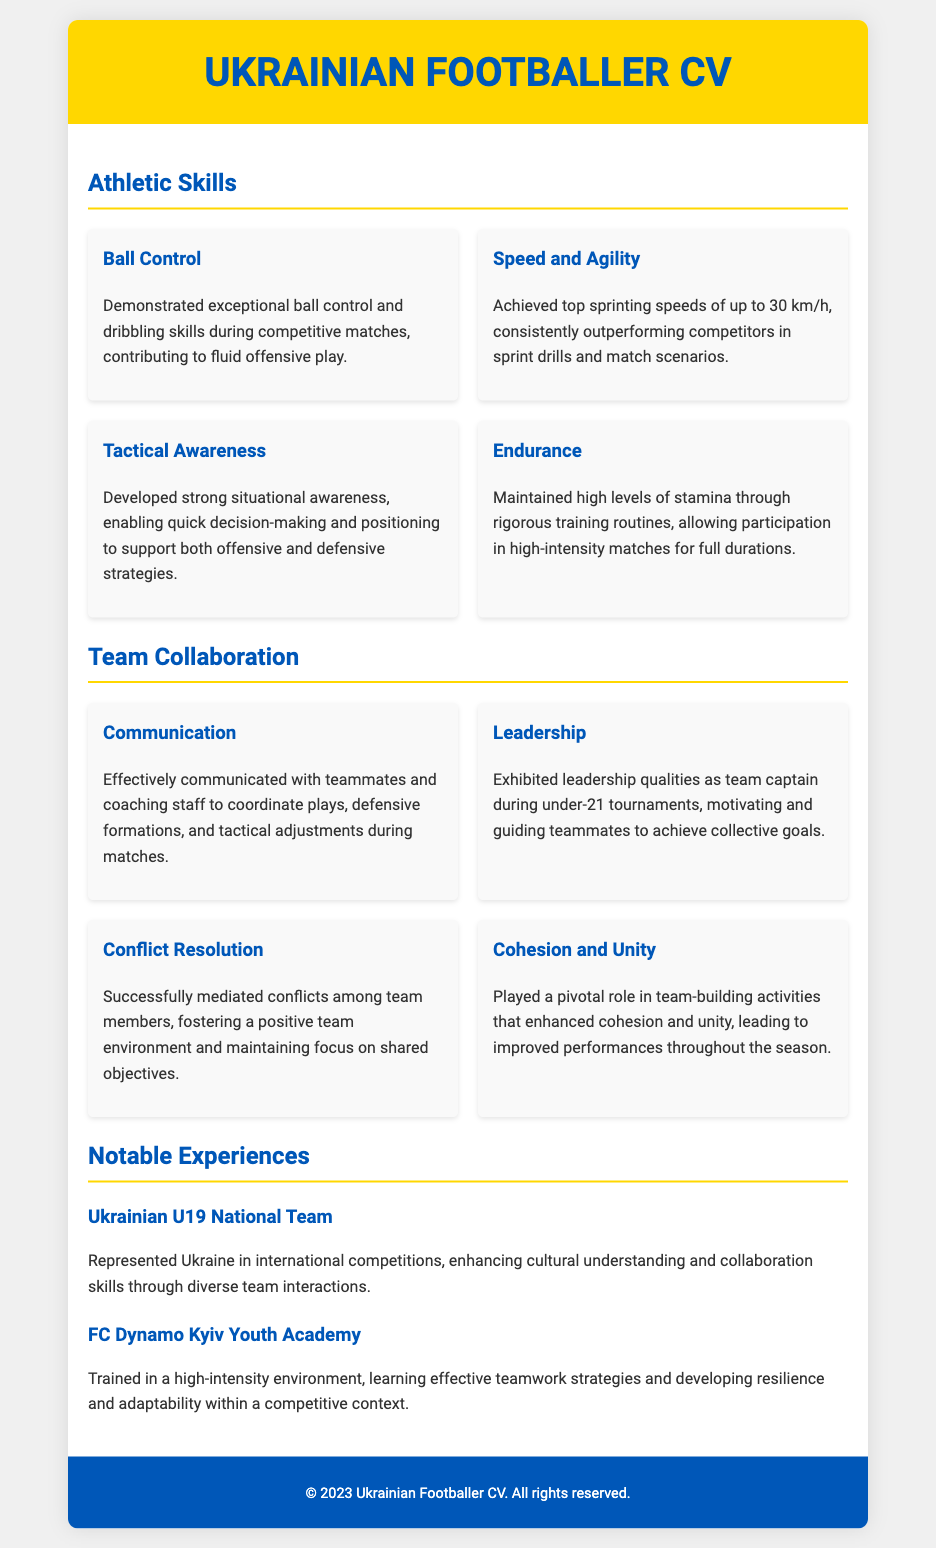What are the athletic skills listed? The document lists four athletic skills: Ball Control, Speed and Agility, Tactical Awareness, and Endurance.
Answer: Ball Control, Speed and Agility, Tactical Awareness, Endurance What is the top sprinting speed achieved? The top sprinting speed mentioned in the document is noted as a specific figure in kilometers per hour.
Answer: 30 km/h Who was the team captain for under-21 tournaments? The CV highlights that the individual exhibited leadership qualities as team captain in a specific context.
Answer: Team captain What role did the individual play in team-building activities? The document states that the individual played a pivotal role in enhancing a specific team characteristic.
Answer: Cohesion and Unity Which national team was represented in international competitions? The document specifies the national team the individual represented at the international level, providing a national affiliation.
Answer: Ukrainian U19 National Team How is effective communication highlighted? The CV details a specific context in which the individual communicated with others, demonstrating a crucial competency.
Answer: Coordinate plays What is the primary context for training mentioned? The document refers to a specific type of environment where training took place, indicating its intensity.
Answer: High-intensity environment What coaching aspect is emphasized through the communication section? The document conveys that communication is crucial for coordinating certain actions during matches.
Answer: Tactical adjustments 